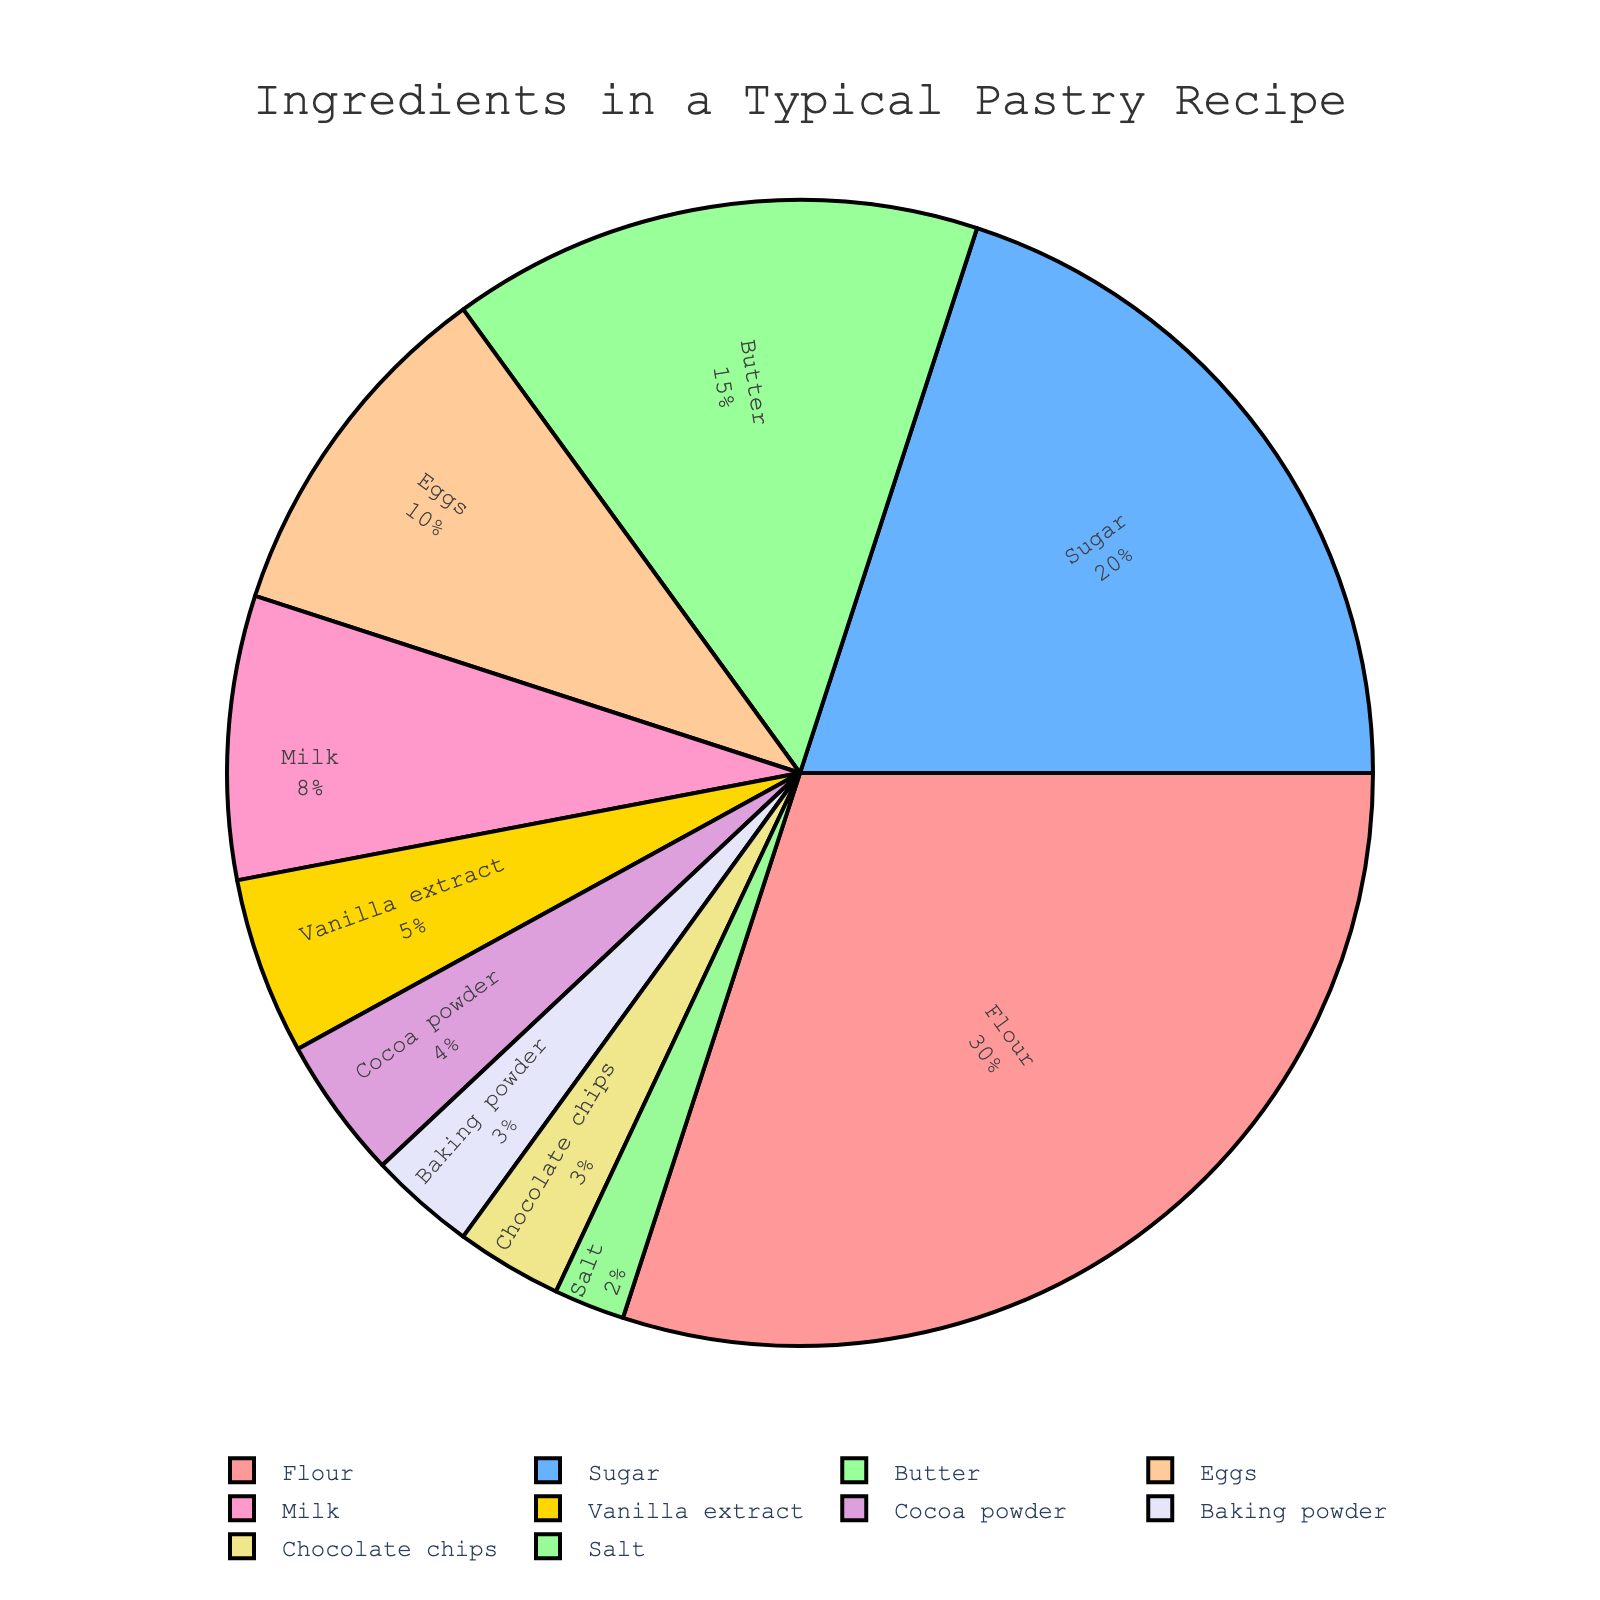Which ingredient is used the most? The ingredient with the highest percentage is used the most. In the figure, Flour has the highest value at 30%.
Answer: Flour What is the total percentage of Sugar, Butter, and Eggs combined? To find the total percentage of Sugar, Butter, and Eggs, sum their individual percentages: 20% (Sugar) + 15% (Butter) + 10% (Eggs) = 45%.
Answer: 45% Which ingredient is represented by the yellow slice? The yellow slice in the figure represents Baking powder, as identified visually.
Answer: Baking powder Is the percentage of Chocolate chips greater than or lesser than Cocoa powder? Chocolate chips have 3%, while Cocoa powder has 4%. Since 3% < 4%, Chocolate chips is lesser.
Answer: Lesser Calculate the difference in percentage between the ingredient with the highest value and the one with the lowest value. The difference between the highest (Flour, 30%) and the lowest (Salt, 2%) is calculated as 30% - 2% = 28%.
Answer: 28% Which two ingredients have the same percentage, and what is that value? From the figure, both Baking powder and Chocolate chips have the same percentage of 3%.
Answer: Baking powder and Chocolate chips, 3% What percentage of ingredients is used for flavoring (Vanilla extract and Cocoa powder)? To find the flavoring percentage, sum Vanilla extract (5%) and Cocoa powder (4%): 5% + 4% = 9%.
Answer: 9% How many more percent is Flour used compared to Butter? Flour is 30% and Butter is 15%. The difference is 30% - 15% = 15%.
Answer: 15% What is the average percentage use of Milk, Vanilla extract, and Baking powder? To find the average, sum their percentages and divide by 3: (8% + 5% + 3%)/3 = 16%/3 ≈ 5.33%.
Answer: 5.33% Which color represents Flour in the pie chart? Flour is represented by the red slice.
Answer: Red 